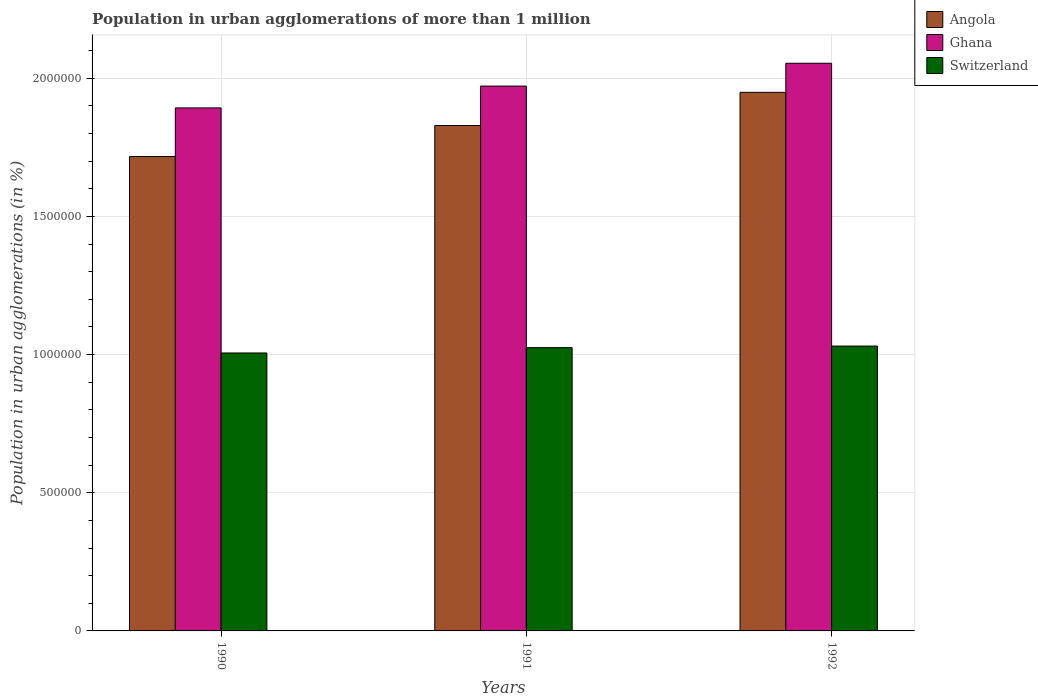How many groups of bars are there?
Ensure brevity in your answer.  3. Are the number of bars per tick equal to the number of legend labels?
Provide a succinct answer. Yes. Are the number of bars on each tick of the X-axis equal?
Provide a short and direct response. Yes. How many bars are there on the 3rd tick from the left?
Provide a succinct answer. 3. How many bars are there on the 1st tick from the right?
Offer a terse response. 3. In how many cases, is the number of bars for a given year not equal to the number of legend labels?
Your answer should be very brief. 0. What is the population in urban agglomerations in Ghana in 1992?
Provide a succinct answer. 2.05e+06. Across all years, what is the maximum population in urban agglomerations in Switzerland?
Give a very brief answer. 1.03e+06. Across all years, what is the minimum population in urban agglomerations in Ghana?
Provide a short and direct response. 1.89e+06. What is the total population in urban agglomerations in Angola in the graph?
Your response must be concise. 5.49e+06. What is the difference between the population in urban agglomerations in Ghana in 1991 and that in 1992?
Keep it short and to the point. -8.26e+04. What is the difference between the population in urban agglomerations in Angola in 1992 and the population in urban agglomerations in Ghana in 1990?
Your answer should be compact. 5.63e+04. What is the average population in urban agglomerations in Angola per year?
Your answer should be compact. 1.83e+06. In the year 1990, what is the difference between the population in urban agglomerations in Switzerland and population in urban agglomerations in Angola?
Ensure brevity in your answer.  -7.11e+05. In how many years, is the population in urban agglomerations in Ghana greater than 1300000 %?
Provide a short and direct response. 3. What is the ratio of the population in urban agglomerations in Angola in 1991 to that in 1992?
Give a very brief answer. 0.94. Is the population in urban agglomerations in Switzerland in 1990 less than that in 1991?
Your answer should be compact. Yes. What is the difference between the highest and the second highest population in urban agglomerations in Switzerland?
Provide a short and direct response. 5764. What is the difference between the highest and the lowest population in urban agglomerations in Switzerland?
Provide a short and direct response. 2.50e+04. What does the 1st bar from the right in 1990 represents?
Your response must be concise. Switzerland. How many bars are there?
Ensure brevity in your answer.  9. How many years are there in the graph?
Provide a succinct answer. 3. What is the difference between two consecutive major ticks on the Y-axis?
Your answer should be very brief. 5.00e+05. Are the values on the major ticks of Y-axis written in scientific E-notation?
Give a very brief answer. No. Does the graph contain any zero values?
Provide a succinct answer. No. Does the graph contain grids?
Offer a very short reply. Yes. How many legend labels are there?
Offer a terse response. 3. What is the title of the graph?
Give a very brief answer. Population in urban agglomerations of more than 1 million. What is the label or title of the Y-axis?
Keep it short and to the point. Population in urban agglomerations (in %). What is the Population in urban agglomerations (in %) in Angola in 1990?
Offer a very short reply. 1.72e+06. What is the Population in urban agglomerations (in %) of Ghana in 1990?
Ensure brevity in your answer.  1.89e+06. What is the Population in urban agglomerations (in %) in Switzerland in 1990?
Keep it short and to the point. 1.01e+06. What is the Population in urban agglomerations (in %) in Angola in 1991?
Provide a short and direct response. 1.83e+06. What is the Population in urban agglomerations (in %) in Ghana in 1991?
Make the answer very short. 1.97e+06. What is the Population in urban agglomerations (in %) of Switzerland in 1991?
Provide a succinct answer. 1.03e+06. What is the Population in urban agglomerations (in %) of Angola in 1992?
Give a very brief answer. 1.95e+06. What is the Population in urban agglomerations (in %) in Ghana in 1992?
Ensure brevity in your answer.  2.05e+06. What is the Population in urban agglomerations (in %) of Switzerland in 1992?
Offer a terse response. 1.03e+06. Across all years, what is the maximum Population in urban agglomerations (in %) in Angola?
Offer a very short reply. 1.95e+06. Across all years, what is the maximum Population in urban agglomerations (in %) in Ghana?
Provide a short and direct response. 2.05e+06. Across all years, what is the maximum Population in urban agglomerations (in %) of Switzerland?
Your answer should be very brief. 1.03e+06. Across all years, what is the minimum Population in urban agglomerations (in %) of Angola?
Offer a terse response. 1.72e+06. Across all years, what is the minimum Population in urban agglomerations (in %) in Ghana?
Give a very brief answer. 1.89e+06. Across all years, what is the minimum Population in urban agglomerations (in %) of Switzerland?
Offer a very short reply. 1.01e+06. What is the total Population in urban agglomerations (in %) in Angola in the graph?
Your response must be concise. 5.49e+06. What is the total Population in urban agglomerations (in %) of Ghana in the graph?
Your answer should be very brief. 5.92e+06. What is the total Population in urban agglomerations (in %) of Switzerland in the graph?
Your response must be concise. 3.06e+06. What is the difference between the Population in urban agglomerations (in %) of Angola in 1990 and that in 1991?
Ensure brevity in your answer.  -1.12e+05. What is the difference between the Population in urban agglomerations (in %) of Ghana in 1990 and that in 1991?
Your answer should be compact. -7.90e+04. What is the difference between the Population in urban agglomerations (in %) of Switzerland in 1990 and that in 1991?
Your answer should be compact. -1.93e+04. What is the difference between the Population in urban agglomerations (in %) of Angola in 1990 and that in 1992?
Keep it short and to the point. -2.32e+05. What is the difference between the Population in urban agglomerations (in %) in Ghana in 1990 and that in 1992?
Offer a very short reply. -1.62e+05. What is the difference between the Population in urban agglomerations (in %) in Switzerland in 1990 and that in 1992?
Offer a terse response. -2.50e+04. What is the difference between the Population in urban agglomerations (in %) of Angola in 1991 and that in 1992?
Provide a short and direct response. -1.20e+05. What is the difference between the Population in urban agglomerations (in %) in Ghana in 1991 and that in 1992?
Your response must be concise. -8.26e+04. What is the difference between the Population in urban agglomerations (in %) in Switzerland in 1991 and that in 1992?
Make the answer very short. -5764. What is the difference between the Population in urban agglomerations (in %) of Angola in 1990 and the Population in urban agglomerations (in %) of Ghana in 1991?
Make the answer very short. -2.55e+05. What is the difference between the Population in urban agglomerations (in %) in Angola in 1990 and the Population in urban agglomerations (in %) in Switzerland in 1991?
Ensure brevity in your answer.  6.91e+05. What is the difference between the Population in urban agglomerations (in %) of Ghana in 1990 and the Population in urban agglomerations (in %) of Switzerland in 1991?
Give a very brief answer. 8.68e+05. What is the difference between the Population in urban agglomerations (in %) in Angola in 1990 and the Population in urban agglomerations (in %) in Ghana in 1992?
Provide a short and direct response. -3.38e+05. What is the difference between the Population in urban agglomerations (in %) of Angola in 1990 and the Population in urban agglomerations (in %) of Switzerland in 1992?
Your answer should be compact. 6.86e+05. What is the difference between the Population in urban agglomerations (in %) in Ghana in 1990 and the Population in urban agglomerations (in %) in Switzerland in 1992?
Your answer should be very brief. 8.62e+05. What is the difference between the Population in urban agglomerations (in %) of Angola in 1991 and the Population in urban agglomerations (in %) of Ghana in 1992?
Give a very brief answer. -2.25e+05. What is the difference between the Population in urban agglomerations (in %) in Angola in 1991 and the Population in urban agglomerations (in %) in Switzerland in 1992?
Provide a short and direct response. 7.98e+05. What is the difference between the Population in urban agglomerations (in %) of Ghana in 1991 and the Population in urban agglomerations (in %) of Switzerland in 1992?
Provide a succinct answer. 9.41e+05. What is the average Population in urban agglomerations (in %) in Angola per year?
Offer a terse response. 1.83e+06. What is the average Population in urban agglomerations (in %) of Ghana per year?
Make the answer very short. 1.97e+06. What is the average Population in urban agglomerations (in %) of Switzerland per year?
Provide a succinct answer. 1.02e+06. In the year 1990, what is the difference between the Population in urban agglomerations (in %) in Angola and Population in urban agglomerations (in %) in Ghana?
Ensure brevity in your answer.  -1.76e+05. In the year 1990, what is the difference between the Population in urban agglomerations (in %) in Angola and Population in urban agglomerations (in %) in Switzerland?
Keep it short and to the point. 7.11e+05. In the year 1990, what is the difference between the Population in urban agglomerations (in %) of Ghana and Population in urban agglomerations (in %) of Switzerland?
Offer a terse response. 8.87e+05. In the year 1991, what is the difference between the Population in urban agglomerations (in %) of Angola and Population in urban agglomerations (in %) of Ghana?
Offer a terse response. -1.43e+05. In the year 1991, what is the difference between the Population in urban agglomerations (in %) of Angola and Population in urban agglomerations (in %) of Switzerland?
Make the answer very short. 8.04e+05. In the year 1991, what is the difference between the Population in urban agglomerations (in %) in Ghana and Population in urban agglomerations (in %) in Switzerland?
Offer a terse response. 9.47e+05. In the year 1992, what is the difference between the Population in urban agglomerations (in %) of Angola and Population in urban agglomerations (in %) of Ghana?
Ensure brevity in your answer.  -1.05e+05. In the year 1992, what is the difference between the Population in urban agglomerations (in %) of Angola and Population in urban agglomerations (in %) of Switzerland?
Give a very brief answer. 9.18e+05. In the year 1992, what is the difference between the Population in urban agglomerations (in %) in Ghana and Population in urban agglomerations (in %) in Switzerland?
Provide a succinct answer. 1.02e+06. What is the ratio of the Population in urban agglomerations (in %) in Angola in 1990 to that in 1991?
Provide a short and direct response. 0.94. What is the ratio of the Population in urban agglomerations (in %) in Ghana in 1990 to that in 1991?
Ensure brevity in your answer.  0.96. What is the ratio of the Population in urban agglomerations (in %) in Switzerland in 1990 to that in 1991?
Your answer should be very brief. 0.98. What is the ratio of the Population in urban agglomerations (in %) of Angola in 1990 to that in 1992?
Offer a very short reply. 0.88. What is the ratio of the Population in urban agglomerations (in %) of Ghana in 1990 to that in 1992?
Your answer should be compact. 0.92. What is the ratio of the Population in urban agglomerations (in %) in Switzerland in 1990 to that in 1992?
Provide a short and direct response. 0.98. What is the ratio of the Population in urban agglomerations (in %) of Angola in 1991 to that in 1992?
Provide a succinct answer. 0.94. What is the ratio of the Population in urban agglomerations (in %) in Ghana in 1991 to that in 1992?
Your response must be concise. 0.96. What is the difference between the highest and the second highest Population in urban agglomerations (in %) of Angola?
Offer a terse response. 1.20e+05. What is the difference between the highest and the second highest Population in urban agglomerations (in %) of Ghana?
Provide a succinct answer. 8.26e+04. What is the difference between the highest and the second highest Population in urban agglomerations (in %) in Switzerland?
Offer a very short reply. 5764. What is the difference between the highest and the lowest Population in urban agglomerations (in %) in Angola?
Give a very brief answer. 2.32e+05. What is the difference between the highest and the lowest Population in urban agglomerations (in %) in Ghana?
Your answer should be very brief. 1.62e+05. What is the difference between the highest and the lowest Population in urban agglomerations (in %) of Switzerland?
Your answer should be very brief. 2.50e+04. 